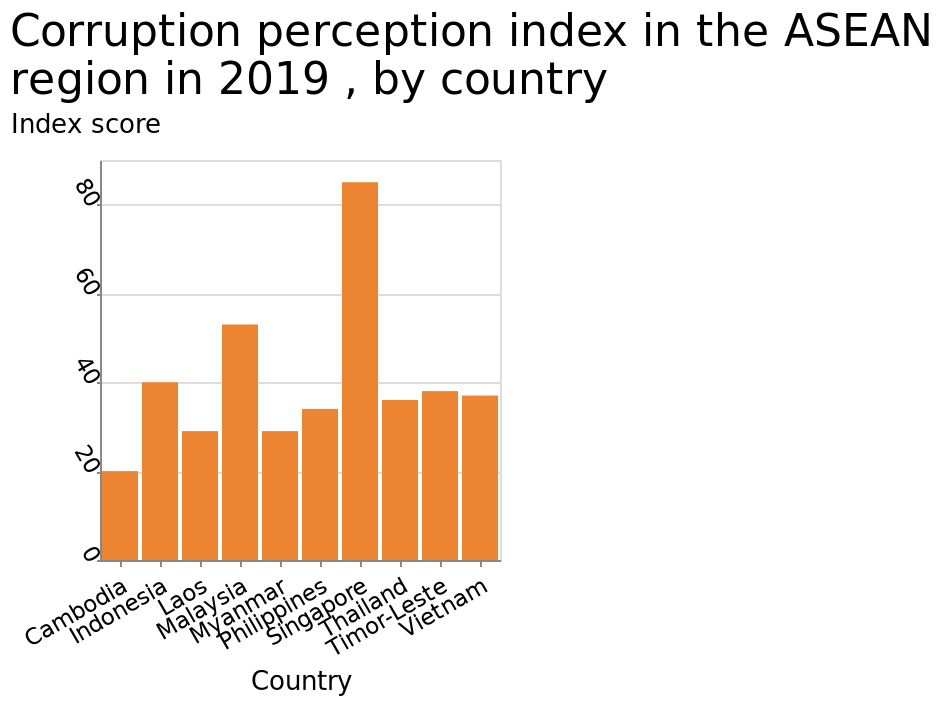<image>
What is the corruption perception index for Malaysia in 2019?  The corruption perception index for Malaysia in 2019 is 55. 